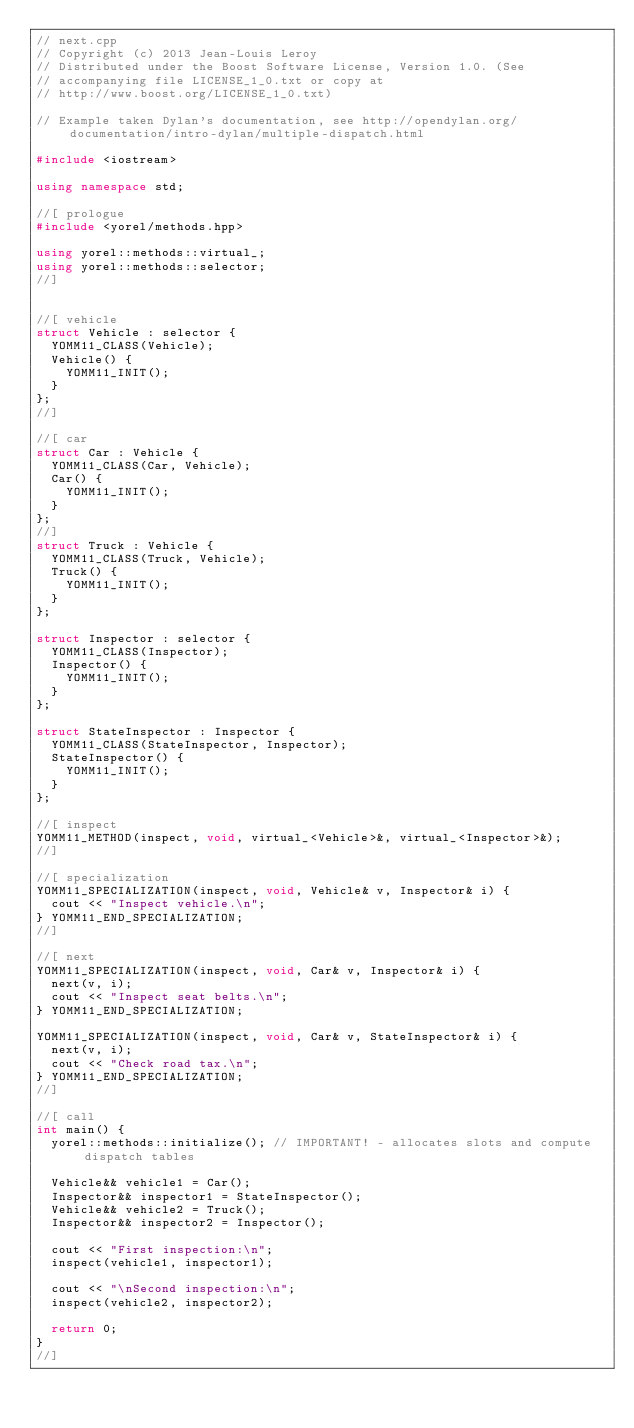<code> <loc_0><loc_0><loc_500><loc_500><_C++_>// next.cpp
// Copyright (c) 2013 Jean-Louis Leroy
// Distributed under the Boost Software License, Version 1.0. (See
// accompanying file LICENSE_1_0.txt or copy at
// http://www.boost.org/LICENSE_1_0.txt)

// Example taken Dylan's documentation, see http://opendylan.org/documentation/intro-dylan/multiple-dispatch.html

#include <iostream>

using namespace std;

//[ prologue
#include <yorel/methods.hpp>

using yorel::methods::virtual_;
using yorel::methods::selector;
//]


//[ vehicle
struct Vehicle : selector {
  YOMM11_CLASS(Vehicle);
  Vehicle() {
    YOMM11_INIT();
  }
};
//]

//[ car
struct Car : Vehicle {
  YOMM11_CLASS(Car, Vehicle);
  Car() {
    YOMM11_INIT();
  }
};
//]
struct Truck : Vehicle {
  YOMM11_CLASS(Truck, Vehicle);
  Truck() {
    YOMM11_INIT();
  }
};

struct Inspector : selector {
  YOMM11_CLASS(Inspector);
  Inspector() {
    YOMM11_INIT();
  }
};

struct StateInspector : Inspector {
  YOMM11_CLASS(StateInspector, Inspector);
  StateInspector() {
    YOMM11_INIT();
  }
};

//[ inspect
YOMM11_METHOD(inspect, void, virtual_<Vehicle>&, virtual_<Inspector>&);
//]

//[ specialization
YOMM11_SPECIALIZATION(inspect, void, Vehicle& v, Inspector& i) {
  cout << "Inspect vehicle.\n";
} YOMM11_END_SPECIALIZATION;
//]

//[ next
YOMM11_SPECIALIZATION(inspect, void, Car& v, Inspector& i) {
  next(v, i);
  cout << "Inspect seat belts.\n";
} YOMM11_END_SPECIALIZATION;

YOMM11_SPECIALIZATION(inspect, void, Car& v, StateInspector& i) {
  next(v, i);
  cout << "Check road tax.\n";
} YOMM11_END_SPECIALIZATION;
//]

//[ call
int main() {
  yorel::methods::initialize(); // IMPORTANT! - allocates slots and compute dispatch tables

  Vehicle&& vehicle1 = Car();
  Inspector&& inspector1 = StateInspector();
  Vehicle&& vehicle2 = Truck();
  Inspector&& inspector2 = Inspector();

  cout << "First inspection:\n";
  inspect(vehicle1, inspector1);

  cout << "\nSecond inspection:\n";
  inspect(vehicle2, inspector2);

  return 0;
}
//]
</code> 